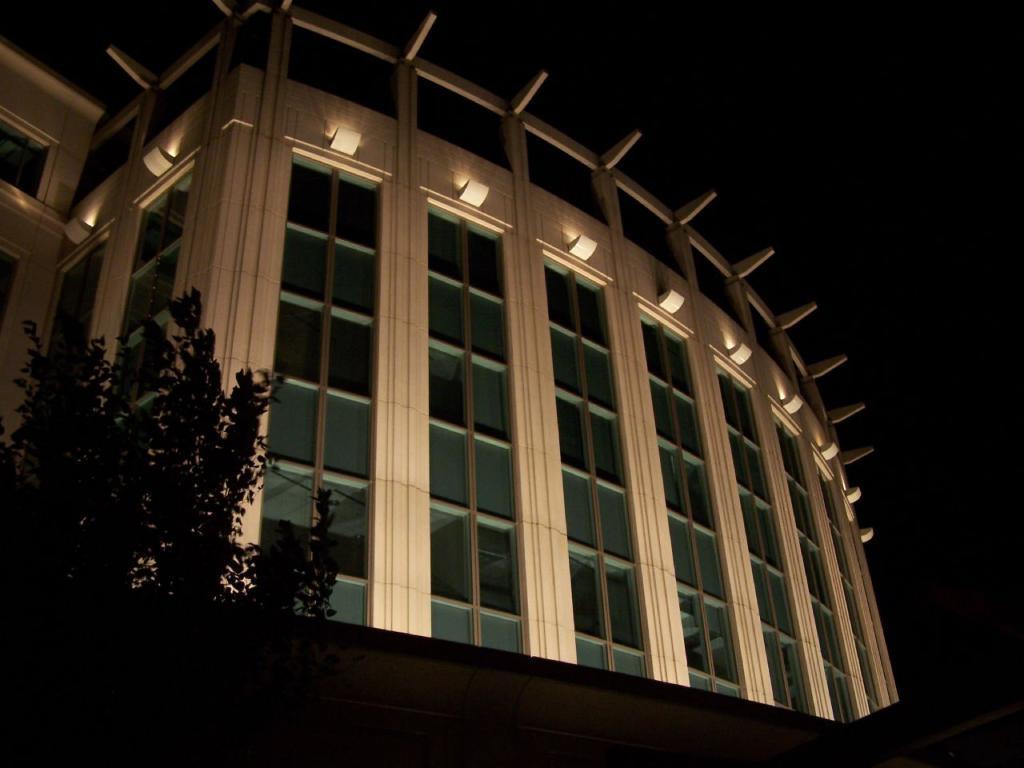In one or two sentences, can you explain what this image depicts? In this image I can see few plants, background I can see the building in white color and I can also see few glass windows, lights and the sky is in black color. 